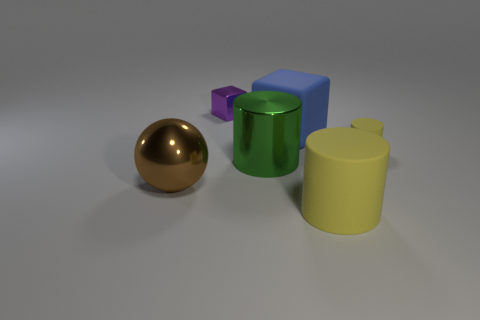What shape is the thing that is behind the ball and on the right side of the big rubber block?
Provide a short and direct response. Cylinder. There is a tiny thing that is behind the small thing right of the shiny object that is behind the large block; what shape is it?
Ensure brevity in your answer.  Cube. There is a object that is in front of the large shiny cylinder and on the right side of the brown shiny thing; what material is it?
Give a very brief answer. Rubber. What number of purple metal balls are the same size as the purple block?
Provide a short and direct response. 0. What number of shiny things are small cyan spheres or tiny cylinders?
Give a very brief answer. 0. What material is the tiny purple thing?
Your answer should be compact. Metal. There is a big green cylinder; what number of yellow objects are to the left of it?
Make the answer very short. 0. Do the large object that is in front of the large metal sphere and the brown ball have the same material?
Keep it short and to the point. No. How many yellow rubber objects are the same shape as the large blue matte object?
Your answer should be very brief. 0. What number of tiny things are matte cubes or yellow matte cylinders?
Provide a succinct answer. 1. 